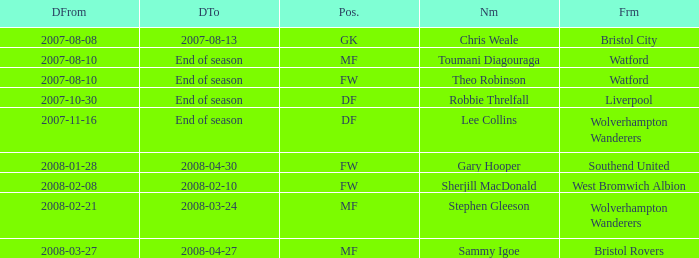What was the Date From for Theo Robinson, who was with the team until the end of season? 2007-08-10. 